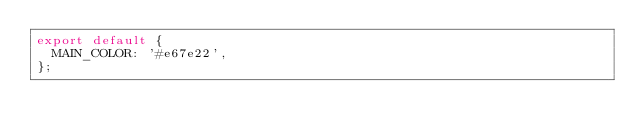Convert code to text. <code><loc_0><loc_0><loc_500><loc_500><_JavaScript_>export default {
  MAIN_COLOR: '#e67e22',
};
</code> 